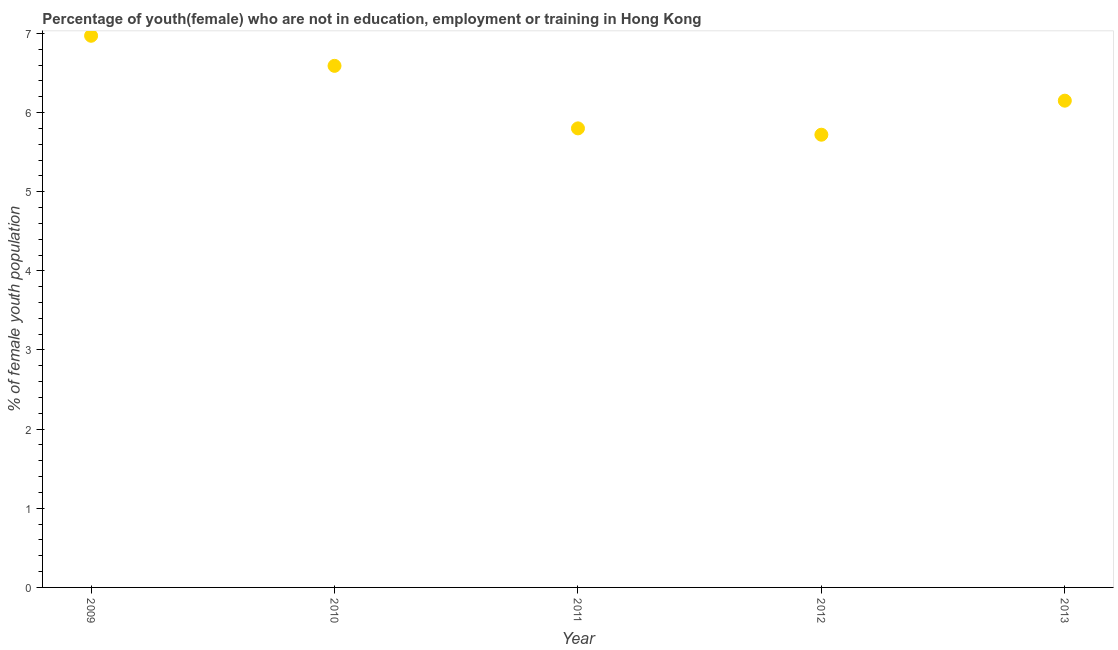What is the unemployed female youth population in 2012?
Provide a succinct answer. 5.72. Across all years, what is the maximum unemployed female youth population?
Your answer should be compact. 6.97. Across all years, what is the minimum unemployed female youth population?
Provide a short and direct response. 5.72. In which year was the unemployed female youth population maximum?
Offer a terse response. 2009. In which year was the unemployed female youth population minimum?
Give a very brief answer. 2012. What is the sum of the unemployed female youth population?
Your answer should be very brief. 31.23. What is the difference between the unemployed female youth population in 2009 and 2012?
Your answer should be compact. 1.25. What is the average unemployed female youth population per year?
Make the answer very short. 6.25. What is the median unemployed female youth population?
Ensure brevity in your answer.  6.15. In how many years, is the unemployed female youth population greater than 6.4 %?
Give a very brief answer. 2. What is the ratio of the unemployed female youth population in 2011 to that in 2013?
Make the answer very short. 0.94. Is the unemployed female youth population in 2009 less than that in 2010?
Provide a succinct answer. No. Is the difference between the unemployed female youth population in 2009 and 2013 greater than the difference between any two years?
Give a very brief answer. No. What is the difference between the highest and the second highest unemployed female youth population?
Keep it short and to the point. 0.38. Is the sum of the unemployed female youth population in 2009 and 2012 greater than the maximum unemployed female youth population across all years?
Provide a succinct answer. Yes. How many dotlines are there?
Provide a succinct answer. 1. How many years are there in the graph?
Offer a very short reply. 5. Does the graph contain any zero values?
Offer a terse response. No. Does the graph contain grids?
Make the answer very short. No. What is the title of the graph?
Offer a terse response. Percentage of youth(female) who are not in education, employment or training in Hong Kong. What is the label or title of the X-axis?
Keep it short and to the point. Year. What is the label or title of the Y-axis?
Your answer should be compact. % of female youth population. What is the % of female youth population in 2009?
Give a very brief answer. 6.97. What is the % of female youth population in 2010?
Your answer should be very brief. 6.59. What is the % of female youth population in 2011?
Your response must be concise. 5.8. What is the % of female youth population in 2012?
Provide a short and direct response. 5.72. What is the % of female youth population in 2013?
Your answer should be very brief. 6.15. What is the difference between the % of female youth population in 2009 and 2010?
Your answer should be compact. 0.38. What is the difference between the % of female youth population in 2009 and 2011?
Offer a terse response. 1.17. What is the difference between the % of female youth population in 2009 and 2013?
Your response must be concise. 0.82. What is the difference between the % of female youth population in 2010 and 2011?
Offer a terse response. 0.79. What is the difference between the % of female youth population in 2010 and 2012?
Provide a succinct answer. 0.87. What is the difference between the % of female youth population in 2010 and 2013?
Your response must be concise. 0.44. What is the difference between the % of female youth population in 2011 and 2013?
Your answer should be compact. -0.35. What is the difference between the % of female youth population in 2012 and 2013?
Your answer should be very brief. -0.43. What is the ratio of the % of female youth population in 2009 to that in 2010?
Provide a succinct answer. 1.06. What is the ratio of the % of female youth population in 2009 to that in 2011?
Give a very brief answer. 1.2. What is the ratio of the % of female youth population in 2009 to that in 2012?
Make the answer very short. 1.22. What is the ratio of the % of female youth population in 2009 to that in 2013?
Keep it short and to the point. 1.13. What is the ratio of the % of female youth population in 2010 to that in 2011?
Ensure brevity in your answer.  1.14. What is the ratio of the % of female youth population in 2010 to that in 2012?
Give a very brief answer. 1.15. What is the ratio of the % of female youth population in 2010 to that in 2013?
Your response must be concise. 1.07. What is the ratio of the % of female youth population in 2011 to that in 2012?
Provide a short and direct response. 1.01. What is the ratio of the % of female youth population in 2011 to that in 2013?
Provide a succinct answer. 0.94. What is the ratio of the % of female youth population in 2012 to that in 2013?
Your answer should be very brief. 0.93. 